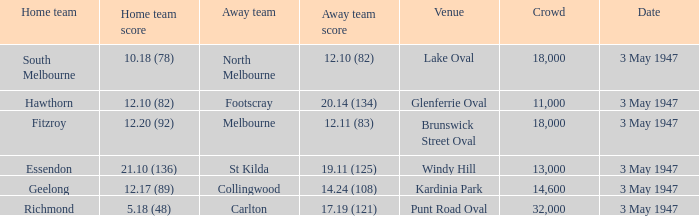Which venue did the away team score 12.10 (82)? Lake Oval. 